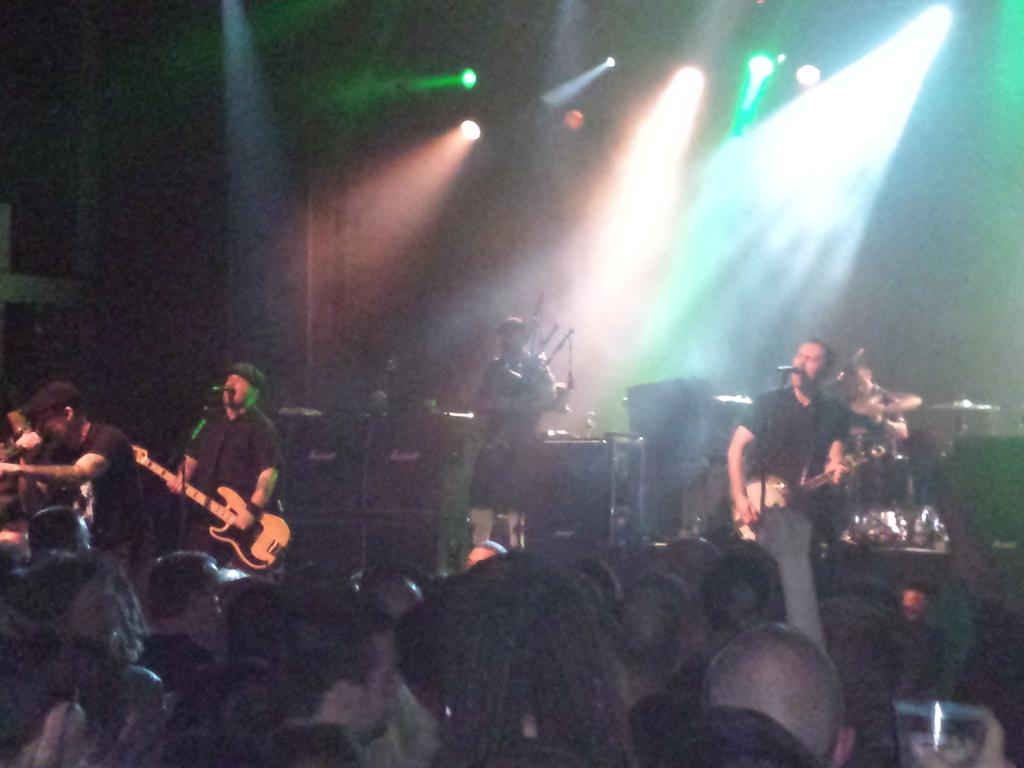What is happening in the image involving a group of people? There is a group of people in the image, and some of them are playing musical instruments. What objects are present in the image that are related to the musical activity? Musical instruments and microphones are visible in the image. What can be seen in the background of the image? There are lights in the background of the image. Where is the police officer standing in the image? There is no police officer present in the image. What type of copy machine can be seen in the image? There is no copy machine present in the image. 